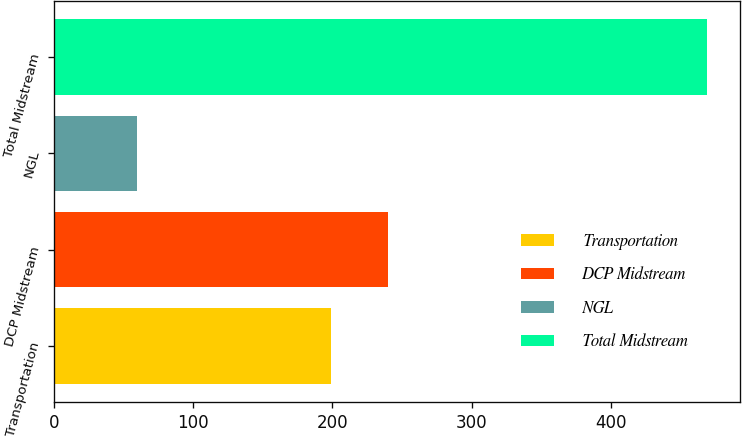<chart> <loc_0><loc_0><loc_500><loc_500><bar_chart><fcel>Transportation<fcel>DCP Midstream<fcel>NGL<fcel>Total Midstream<nl><fcel>199<fcel>239.9<fcel>60<fcel>469<nl></chart> 